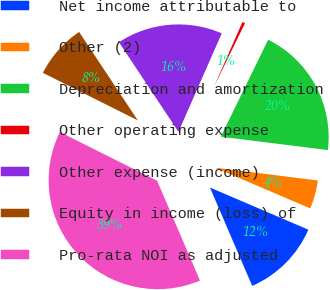Convert chart. <chart><loc_0><loc_0><loc_500><loc_500><pie_chart><fcel>Net income attributable to<fcel>Other (2)<fcel>Depreciation and amortization<fcel>Other operating expense<fcel>Other expense (income)<fcel>Equity in income (loss) of<fcel>Pro-rata NOI as adjusted<nl><fcel>12.1%<fcel>4.46%<fcel>19.74%<fcel>0.64%<fcel>15.92%<fcel>8.28%<fcel>38.84%<nl></chart> 